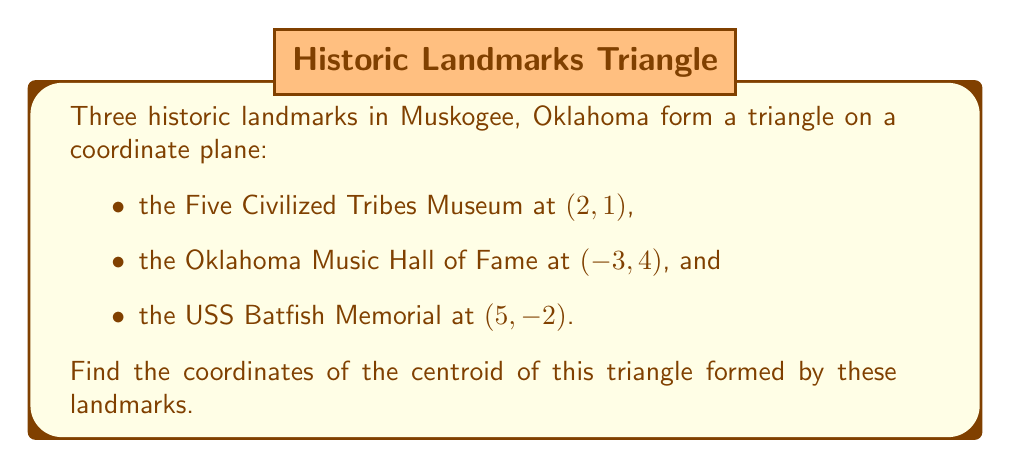Give your solution to this math problem. To find the centroid of a triangle, we need to follow these steps:

1) The centroid of a triangle is located at the intersection of its medians. It divides each median in a 2:1 ratio, with the longer segment closer to the vertex.

2) The coordinates of the centroid can be calculated using the formula:

   $$\left(\frac{x_1 + x_2 + x_3}{3}, \frac{y_1 + y_2 + y_3}{3}\right)$$

   where $(x_1, y_1)$, $(x_2, y_2)$, and $(x_3, y_3)$ are the coordinates of the three vertices.

3) Let's assign our landmarks:
   - Five Civilized Tribes Museum: $(x_1, y_1) = (2, 1)$
   - Oklahoma Music Hall of Fame: $(x_2, y_2) = (-3, 4)$
   - USS Batfish Memorial: $(x_3, y_3) = (5, -2)$

4) Now, let's calculate the x-coordinate of the centroid:

   $$x = \frac{x_1 + x_2 + x_3}{3} = \frac{2 + (-3) + 5}{3} = \frac{4}{3} \approx 1.33$$

5) Next, let's calculate the y-coordinate of the centroid:

   $$y = \frac{y_1 + y_2 + y_3}{3} = \frac{1 + 4 + (-2)}{3} = 1$$

6) Therefore, the coordinates of the centroid are $(\frac{4}{3}, 1)$ or approximately $(1.33, 1)$.

[asy]
import geometry;

pair A = (2,1);
pair B = (-3,4);
pair C = (5,-2);
pair G = (4/3,1);

draw(A--B--C--cycle, blue);
dot(A,red);
dot(B,red);
dot(C,red);
dot(G,green);

label("Five Civilized Tribes Museum (2,1)", A, NE);
label("Oklahoma Music Hall of Fame (-3,4)", B, NW);
label("USS Batfish Memorial (5,-2)", C, SE);
label("Centroid (4/3,1)", G, S);

xaxis(-4,6,Arrow);
yaxis(-3,5,Arrow);
[/asy]
Answer: The coordinates of the centroid are $(\frac{4}{3}, 1)$ or approximately $(1.33, 1)$. 